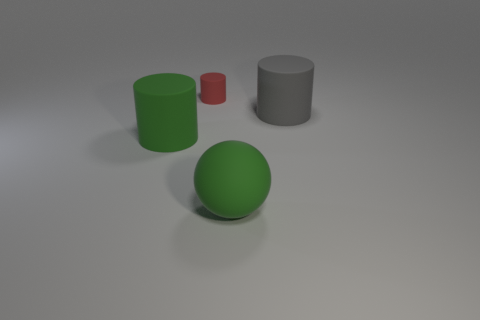Add 4 large yellow metallic things. How many objects exist? 8 Subtract all spheres. How many objects are left? 3 Subtract all large rubber things. Subtract all tiny red matte things. How many objects are left? 0 Add 3 large cylinders. How many large cylinders are left? 5 Add 4 big yellow shiny things. How many big yellow shiny things exist? 4 Subtract 0 purple blocks. How many objects are left? 4 